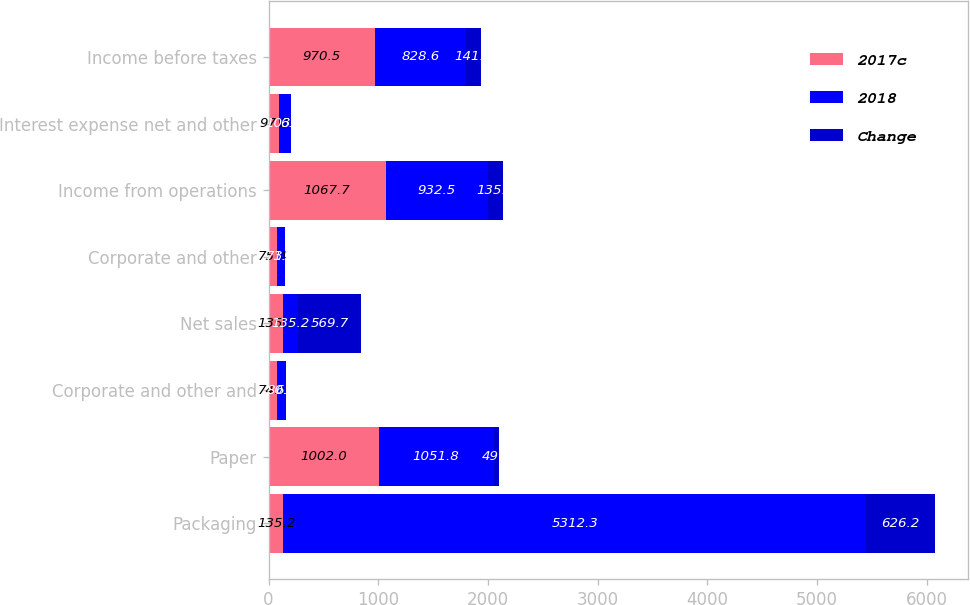<chart> <loc_0><loc_0><loc_500><loc_500><stacked_bar_chart><ecel><fcel>Packaging<fcel>Paper<fcel>Corporate and other and<fcel>Net sales<fcel>Corporate and other<fcel>Income from operations<fcel>Interest expense net and other<fcel>Income before taxes<nl><fcel>2017c<fcel>135.2<fcel>1002<fcel>74.1<fcel>135.2<fcel>75.4<fcel>1067.7<fcel>97.2<fcel>970.5<nl><fcel>2018<fcel>5312.3<fcel>1051.8<fcel>80.8<fcel>135.2<fcel>71.8<fcel>932.5<fcel>103.9<fcel>828.6<nl><fcel>Change<fcel>626.2<fcel>49.8<fcel>6.7<fcel>569.7<fcel>3.6<fcel>135.2<fcel>6.7<fcel>141.9<nl></chart> 